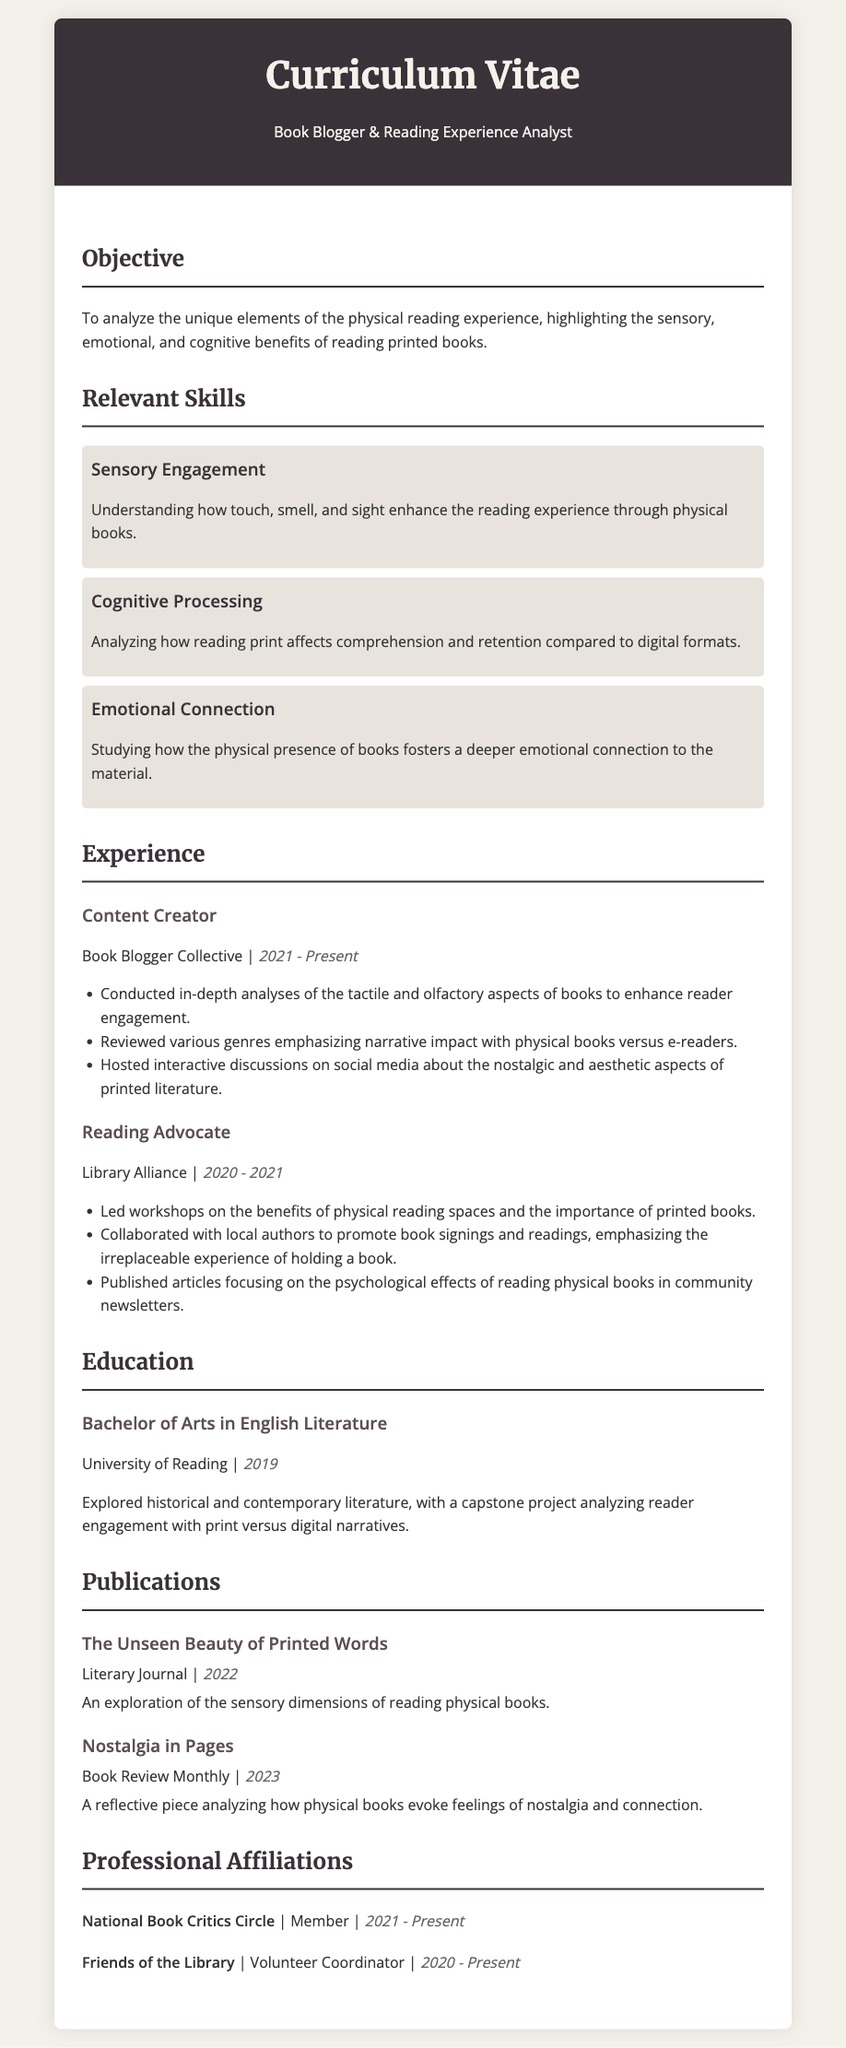what is the title of the document? The title of the document is indicated in the header section of the document: "Curriculum Vitae".
Answer: Curriculum Vitae who is the author of this CV? The author is identified in the header as a "Book Blogger & Reading Experience Analyst".
Answer: Book Blogger & Reading Experience Analyst what is the date of the Bachelor's degree? The date of the Bachelor's degree can be found in the Education section, which states "2019".
Answer: 2019 how many relevant skills are listed? The skills are outlined in the "Relevant Skills" section, with three distinct skills mentioned.
Answer: 3 what is the name of the publication discussing the sensory dimensions of reading? The name of the publication is found in the Publications section under the first publication listed: "The Unseen Beauty of Printed Words".
Answer: The Unseen Beauty of Printed Words who did the author collaborate with to promote reading events? The collaboration partner is mentioned in the Experience section, specifically the "Library Alliance".
Answer: local authors what role does the author hold in "Friends of the Library"? The author's position in the organization is indicated in the Professional Affiliations section.
Answer: Volunteer Coordinator what year did the author start working as a content creator? The start year is mentioned in the Experience section related to the "Book Blogger Collective".
Answer: 2021 which journal published an article in 2023? The publication year is mentioned next to the title in the Publications section, referring to "Book Review Monthly".
Answer: Book Review Monthly 